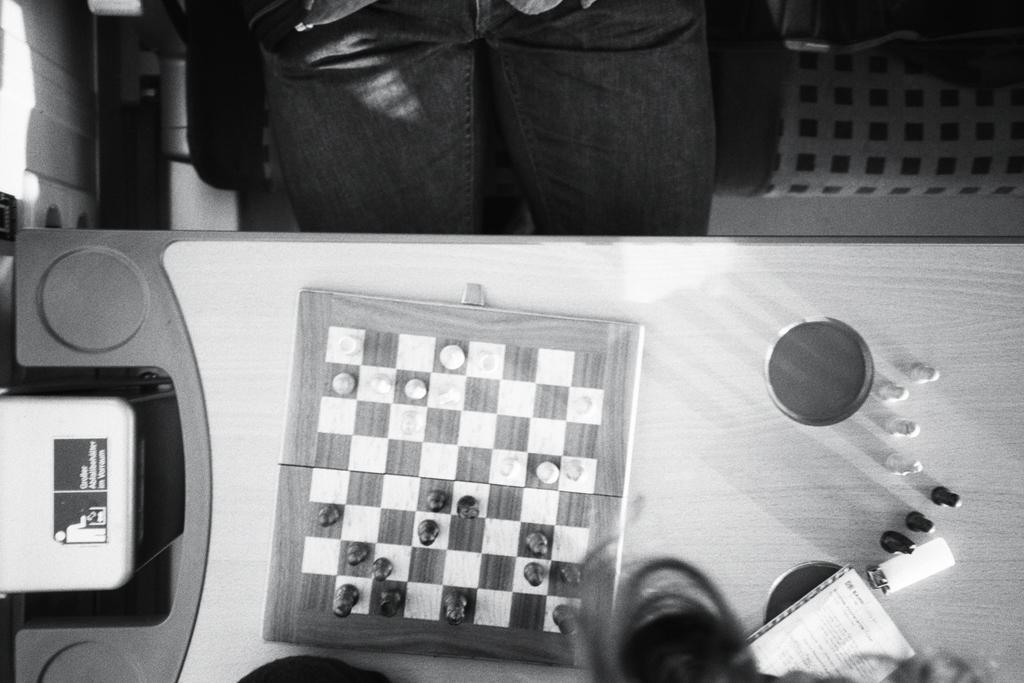What is the main subject of the image? There is a chess board in the image. What else can be seen on the table? There are objects on the table. Can you describe the person in the image? There is a person sitting on a chair in the image. What is the color scheme of the image? The image is in black and white. What type of glue is being used by the person in the image? There is no glue present in the image, and the person is not shown using any glue. 